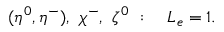Convert formula to latex. <formula><loc_0><loc_0><loc_500><loc_500>( \eta ^ { 0 } , \eta ^ { - } ) , \chi ^ { - } , \zeta ^ { 0 } \colon L _ { e } = 1 .</formula> 